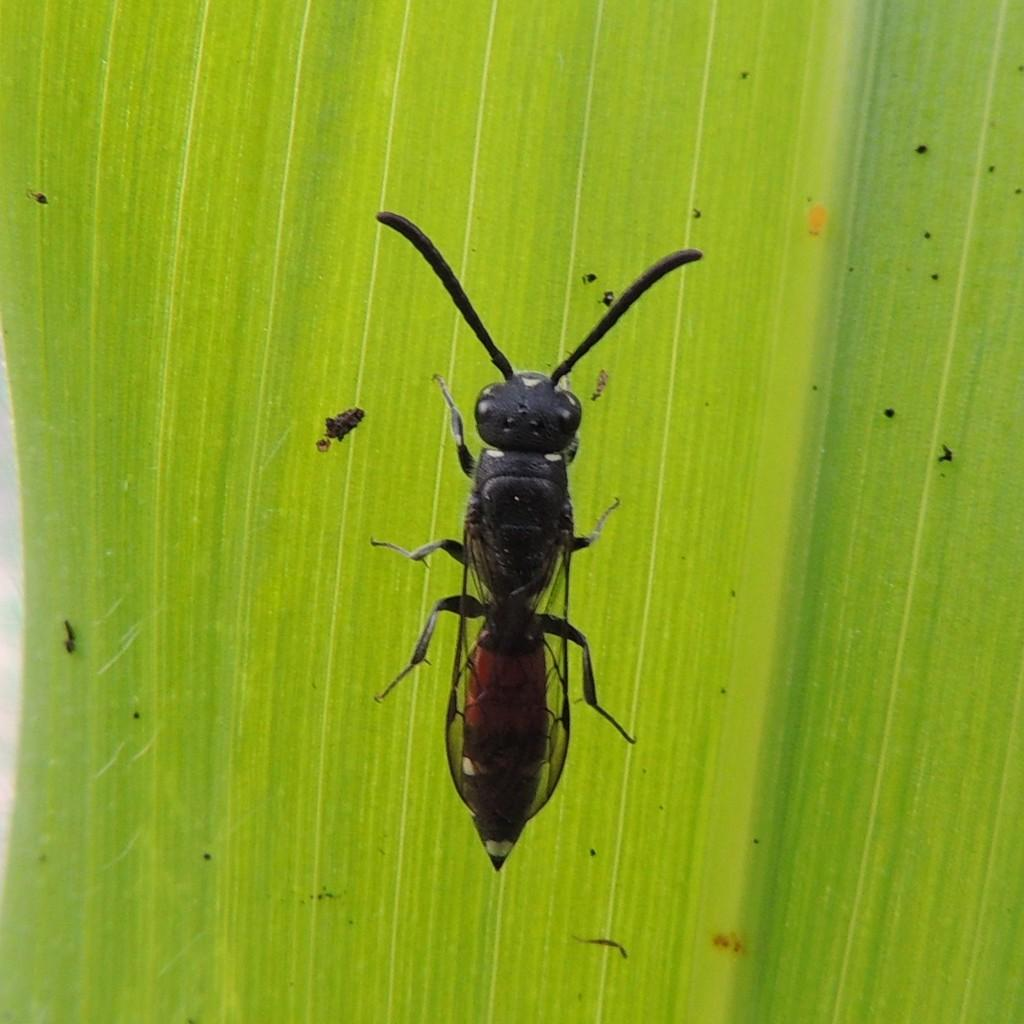What is present on the leaf in the image? There is an insect on the leaf in the image. What can be said about the insect's appearance? The insect is black in color and has antennae. What type of chalk is the insect using to draw on the leaf in the image? There is no chalk present in the image, and insects do not use chalk to draw. 